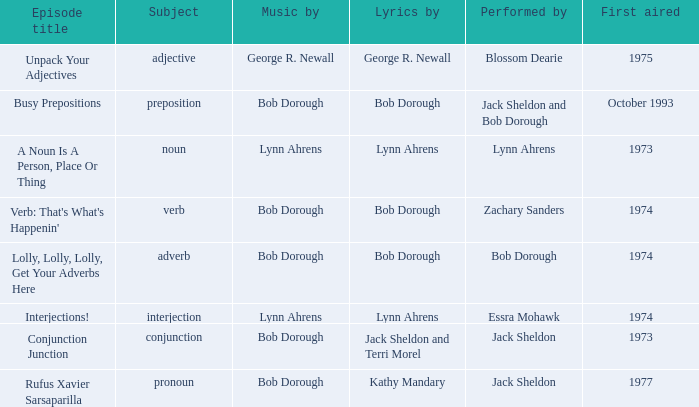Can you give me this table as a dict? {'header': ['Episode title', 'Subject', 'Music by', 'Lyrics by', 'Performed by', 'First aired'], 'rows': [['Unpack Your Adjectives', 'adjective', 'George R. Newall', 'George R. Newall', 'Blossom Dearie', '1975'], ['Busy Prepositions', 'preposition', 'Bob Dorough', 'Bob Dorough', 'Jack Sheldon and Bob Dorough', 'October 1993'], ['A Noun Is A Person, Place Or Thing', 'noun', 'Lynn Ahrens', 'Lynn Ahrens', 'Lynn Ahrens', '1973'], ["Verb: That's What's Happenin'", 'verb', 'Bob Dorough', 'Bob Dorough', 'Zachary Sanders', '1974'], ['Lolly, Lolly, Lolly, Get Your Adverbs Here', 'adverb', 'Bob Dorough', 'Bob Dorough', 'Bob Dorough', '1974'], ['Interjections!', 'interjection', 'Lynn Ahrens', 'Lynn Ahrens', 'Essra Mohawk', '1974'], ['Conjunction Junction', 'conjunction', 'Bob Dorough', 'Jack Sheldon and Terri Morel', 'Jack Sheldon', '1973'], ['Rufus Xavier Sarsaparilla', 'pronoun', 'Bob Dorough', 'Kathy Mandary', 'Jack Sheldon', '1977']]} When zachary sanders is the performer how many first aired are there? 1.0. 